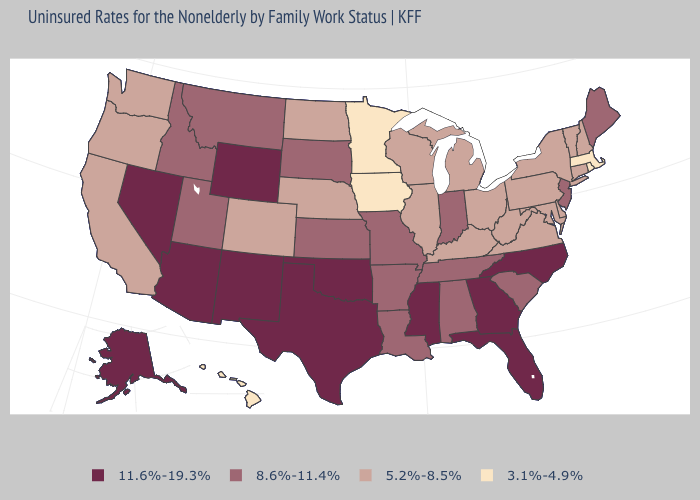Does the map have missing data?
Quick response, please. No. Among the states that border Arkansas , which have the highest value?
Write a very short answer. Mississippi, Oklahoma, Texas. What is the lowest value in the USA?
Quick response, please. 3.1%-4.9%. Is the legend a continuous bar?
Concise answer only. No. Does the first symbol in the legend represent the smallest category?
Concise answer only. No. What is the value of New York?
Keep it brief. 5.2%-8.5%. Which states have the lowest value in the West?
Keep it brief. Hawaii. Name the states that have a value in the range 5.2%-8.5%?
Be succinct. California, Colorado, Connecticut, Delaware, Illinois, Kentucky, Maryland, Michigan, Nebraska, New Hampshire, New York, North Dakota, Ohio, Oregon, Pennsylvania, Vermont, Virginia, Washington, West Virginia, Wisconsin. What is the value of Indiana?
Concise answer only. 8.6%-11.4%. Does the first symbol in the legend represent the smallest category?
Keep it brief. No. What is the highest value in states that border Missouri?
Keep it brief. 11.6%-19.3%. Does Virginia have the highest value in the USA?
Keep it brief. No. What is the highest value in states that border Massachusetts?
Answer briefly. 5.2%-8.5%. Which states have the lowest value in the USA?
Be succinct. Hawaii, Iowa, Massachusetts, Minnesota, Rhode Island. Which states hav the highest value in the West?
Answer briefly. Alaska, Arizona, Nevada, New Mexico, Wyoming. 